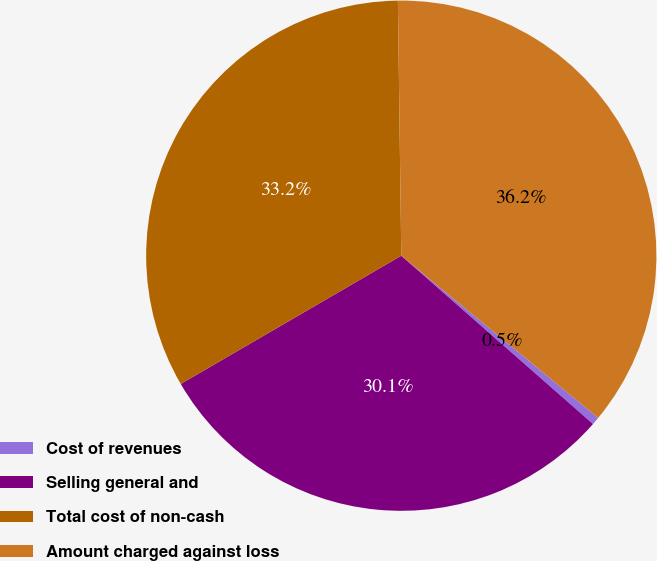Convert chart to OTSL. <chart><loc_0><loc_0><loc_500><loc_500><pie_chart><fcel>Cost of revenues<fcel>Selling general and<fcel>Total cost of non-cash<fcel>Amount charged against loss<nl><fcel>0.5%<fcel>30.15%<fcel>33.17%<fcel>36.18%<nl></chart> 